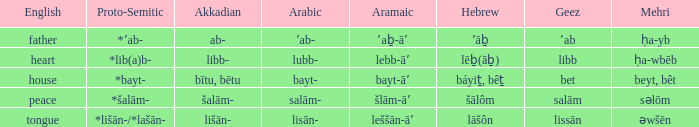If šlām-āʼ is the aramaic, what is the corresponding english? Peace. 